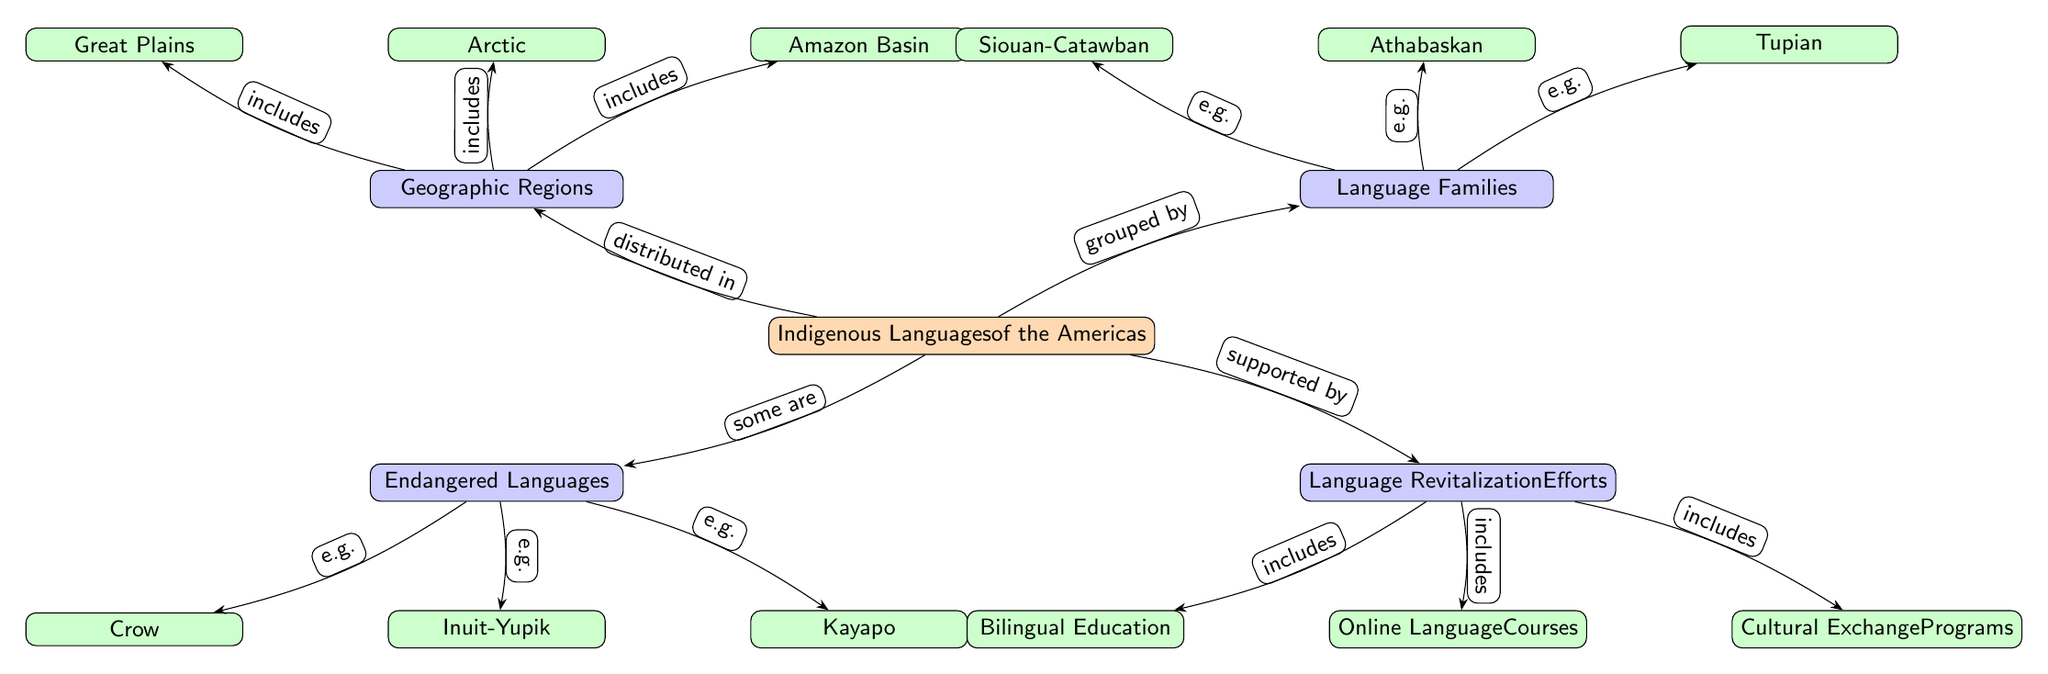What are the four main categories depicted in the diagram? The diagram shows four main categories: Geographic Regions, Language Families, Endangered Languages, and Language Revitalization Efforts.
Answer: Geographic Regions, Language Families, Endangered Languages, Language Revitalization Efforts How many examples are listed under the category of Geographic Regions? The Geographic Regions category lists three examples: Arctic, Great Plains, and Amazon Basin. Therefore, the count is three examples.
Answer: 3 Which language family is associated with the example "Crow"? "Crow" is specifically listed as an example within the Endangered Languages category. The related Language Family for Crow is Siouan-Catawban, as inferred from its position in the diagram.
Answer: Siouan-Catawban What types of revitalization efforts are detailed in the diagram? The Language Revitalization Efforts category contains three types: Online Language Courses, Bilingual Education, and Cultural Exchange Programs.
Answer: Online Language Courses, Bilingual Education, Cultural Exchange Programs Which geographic region includes the example "Amazon Basin"? The Amazon Basin is included under the Geographic Regions category, specifically linked to the Indigenous Languages of the Americas.
Answer: Amazon Basin How many edges connect the main node to its categories? The main node ‘Indigenous Languages of the Americas’ connects to four categories with edges: Geographic Regions, Language Families, Endangered Languages, and Language Revitalization Efforts, resulting in four edges.
Answer: 4 What is the relationship between the main node and the Endangered Languages category? The main node indicates that some Indigenous Languages are classified as Endangered Languages, as demonstrated by the edge labeled "some are" leading to the Endangered Languages category.
Answer: some are Which example under Language Families is situated on the right side of the node for Athabaskan? The example positioned to the right of the Athabaskan node is Tupian, as indicated in the diagram under the Language Families category.
Answer: Tupian 